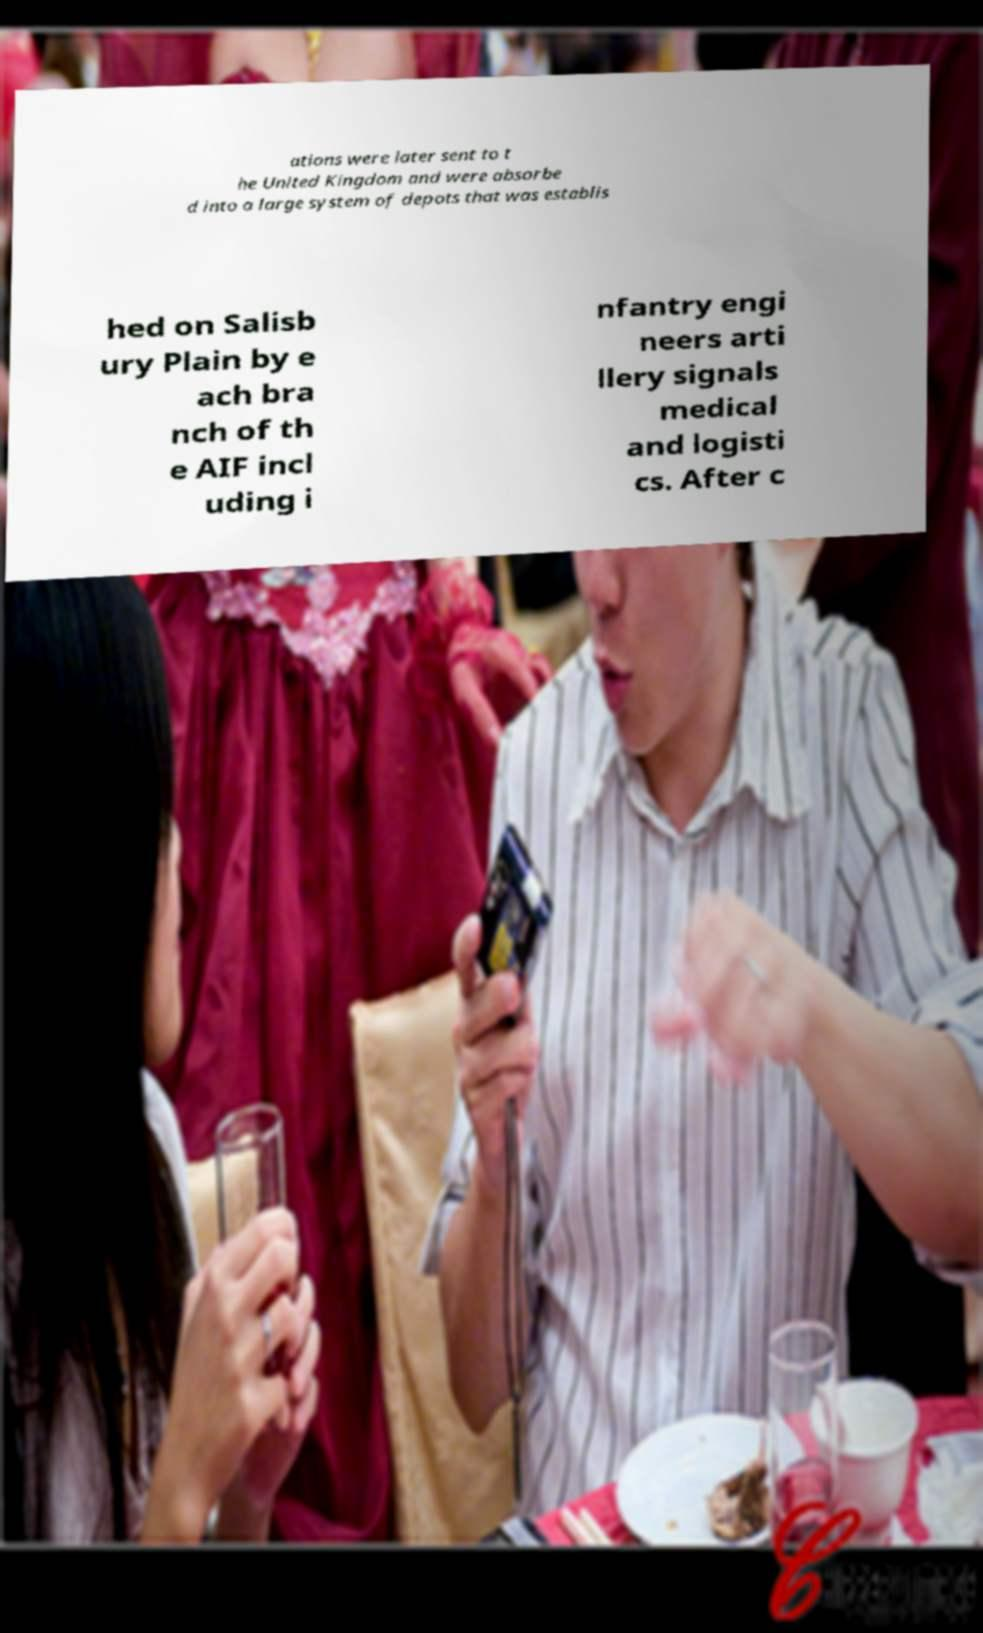Could you extract and type out the text from this image? ations were later sent to t he United Kingdom and were absorbe d into a large system of depots that was establis hed on Salisb ury Plain by e ach bra nch of th e AIF incl uding i nfantry engi neers arti llery signals medical and logisti cs. After c 